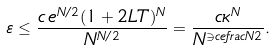<formula> <loc_0><loc_0><loc_500><loc_500>\varepsilon \leq \frac { c \, e ^ { N / 2 } ( 1 + 2 L T ) ^ { N } } { N ^ { N / 2 } } = \frac { c \kappa ^ { N } } { N ^ { \ni c e f r a c { N } { 2 } } } .</formula> 